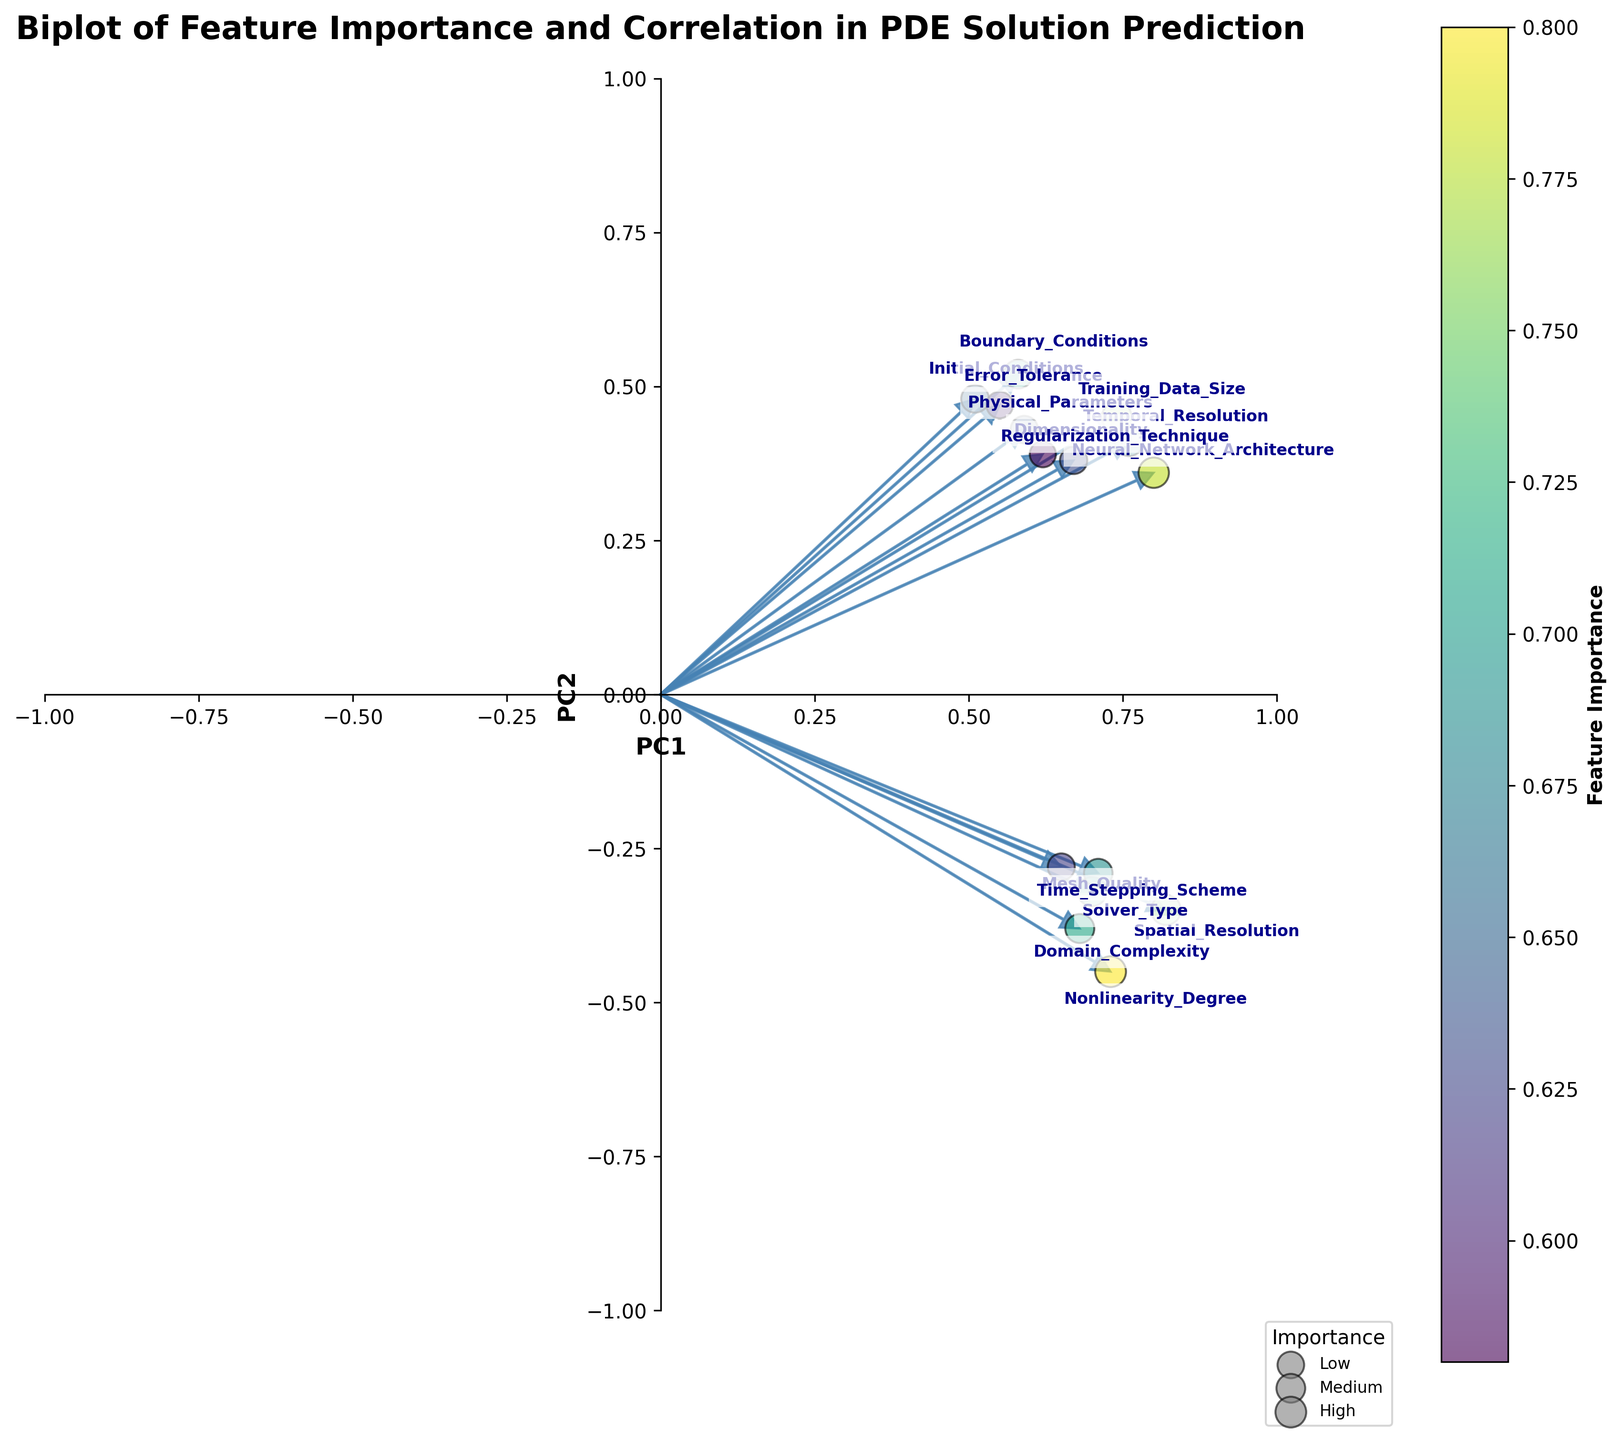What's the title of the figure? The title is located at the top of the figure. It reads "Biplot of Feature Importance and Correlation in PDE Solution Prediction."
Answer: Biplot of Feature Importance and Correlation in PDE Solution Prediction Which feature has the highest importance? By referring to the colorbar and the size of the scatter points, the feature "Nonlinearity_Degree" has the highest importance since its scatter point is the largest and darkest.
Answer: Nonlinearity_Degree Which feature has the smallest PC2 value, and what is it? We need to look for the feature with the smallest PC2 coordinate. "Nonlinearity_Degree" has the smallest PC2 value with a coordinate of -0.45.
Answer: Nonlinearity_Degree, -0.45 How many features have a PC1 value greater than 0.7? By checking the coordinates, there are five features with a PC1 value greater than 0.7: "Spatial_Resolution," "Temporal_Resolution," "Nonlinearity_Degree," "Neural_Network_Architecture," and "Training_Data_Size."
Answer: 5 Which feature has the highest importance but a negative PC1 value? Look for a feature with a large scatter point and a negative PC1. "Mesh_Quality" has this characteristic with an importance of 0.62 and a PC1 value of 0.65.
Answer: Mesh_Quality Compare the PC2 values of "Boundary_Conditions" and "Training_Data_Size." Which one is larger? The PC2 value of "Boundary_Conditions" is 0.52, while "Training_Data_Size" has a PC2 value of 0.45. Therefore, the PC2 value of "Boundary_Conditions" is larger.
Answer: Boundary_Conditions What is the average importance of "Temporal_Resolution" and "Solver_Type"? First, find the importances: "Temporal_Resolution" is 0.68 and "Solver_Type" is 0.72. The average is (0.68 + 0.72) / 2 = 0.70.
Answer: 0.70 Which feature has coordinates closest to the center (0, 0)? Calculate the Euclidean distance of each feature from (0, 0). "Initial_Conditions" with coordinates (0.51, 0.48) is the closest.
Answer: Initial_Conditions What is the importance difference between "Domain_Complexity" and "Error_Tolerance"? "Domain_Complexity" has an importance of 0.71, and "Error_Tolerance" has 0.60. The difference is 0.71 - 0.60 = 0.11.
Answer: 0.11 Are there any features with both negative PC1 and PC2 values? By examining the coordinates, "Nonlinearity_Degree" and "Mesh_Quality" both have negative PC1 and PC2 values.
Answer: Yes 